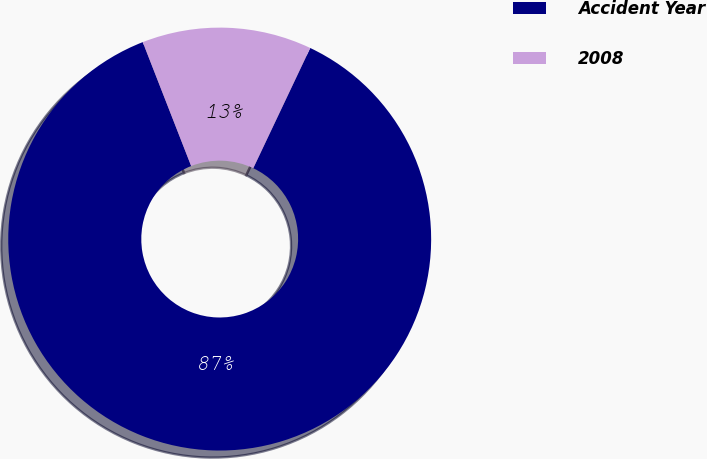Convert chart. <chart><loc_0><loc_0><loc_500><loc_500><pie_chart><fcel>Accident Year<fcel>2008<nl><fcel>87.03%<fcel>12.97%<nl></chart> 